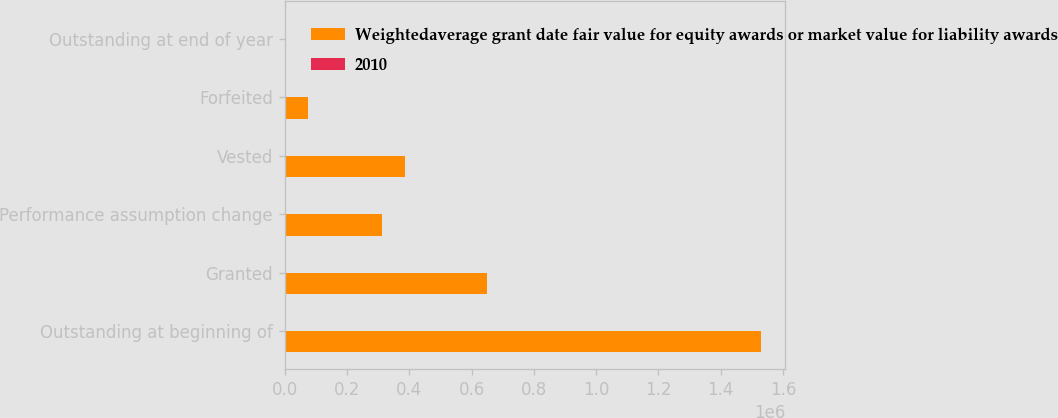Convert chart. <chart><loc_0><loc_0><loc_500><loc_500><stacked_bar_chart><ecel><fcel>Outstanding at beginning of<fcel>Granted<fcel>Performance assumption change<fcel>Vested<fcel>Forfeited<fcel>Outstanding at end of year<nl><fcel>Weightedaverage grant date fair value for equity awards or market value for liability awards<fcel>1.53046e+06<fcel>650407<fcel>313340<fcel>385195<fcel>74564<fcel>39.32<nl><fcel>2010<fcel>37.11<fcel>39.32<fcel>35.87<fcel>38.15<fcel>38.17<fcel>37.82<nl></chart> 